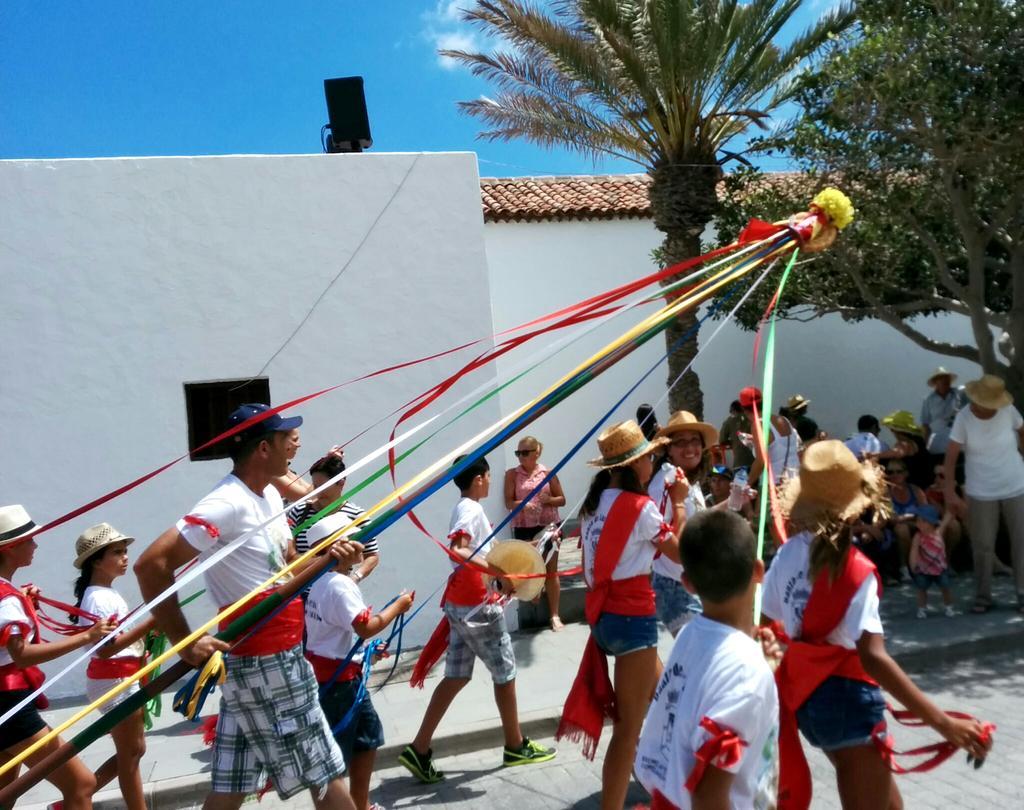Describe this image in one or two sentences. In this image I can see the group of people with white, red and blue color dresses. I can see few people with hats and caps. I can see these people holding the pole which is decorated. In the background I can see the trees, house and the sky. 